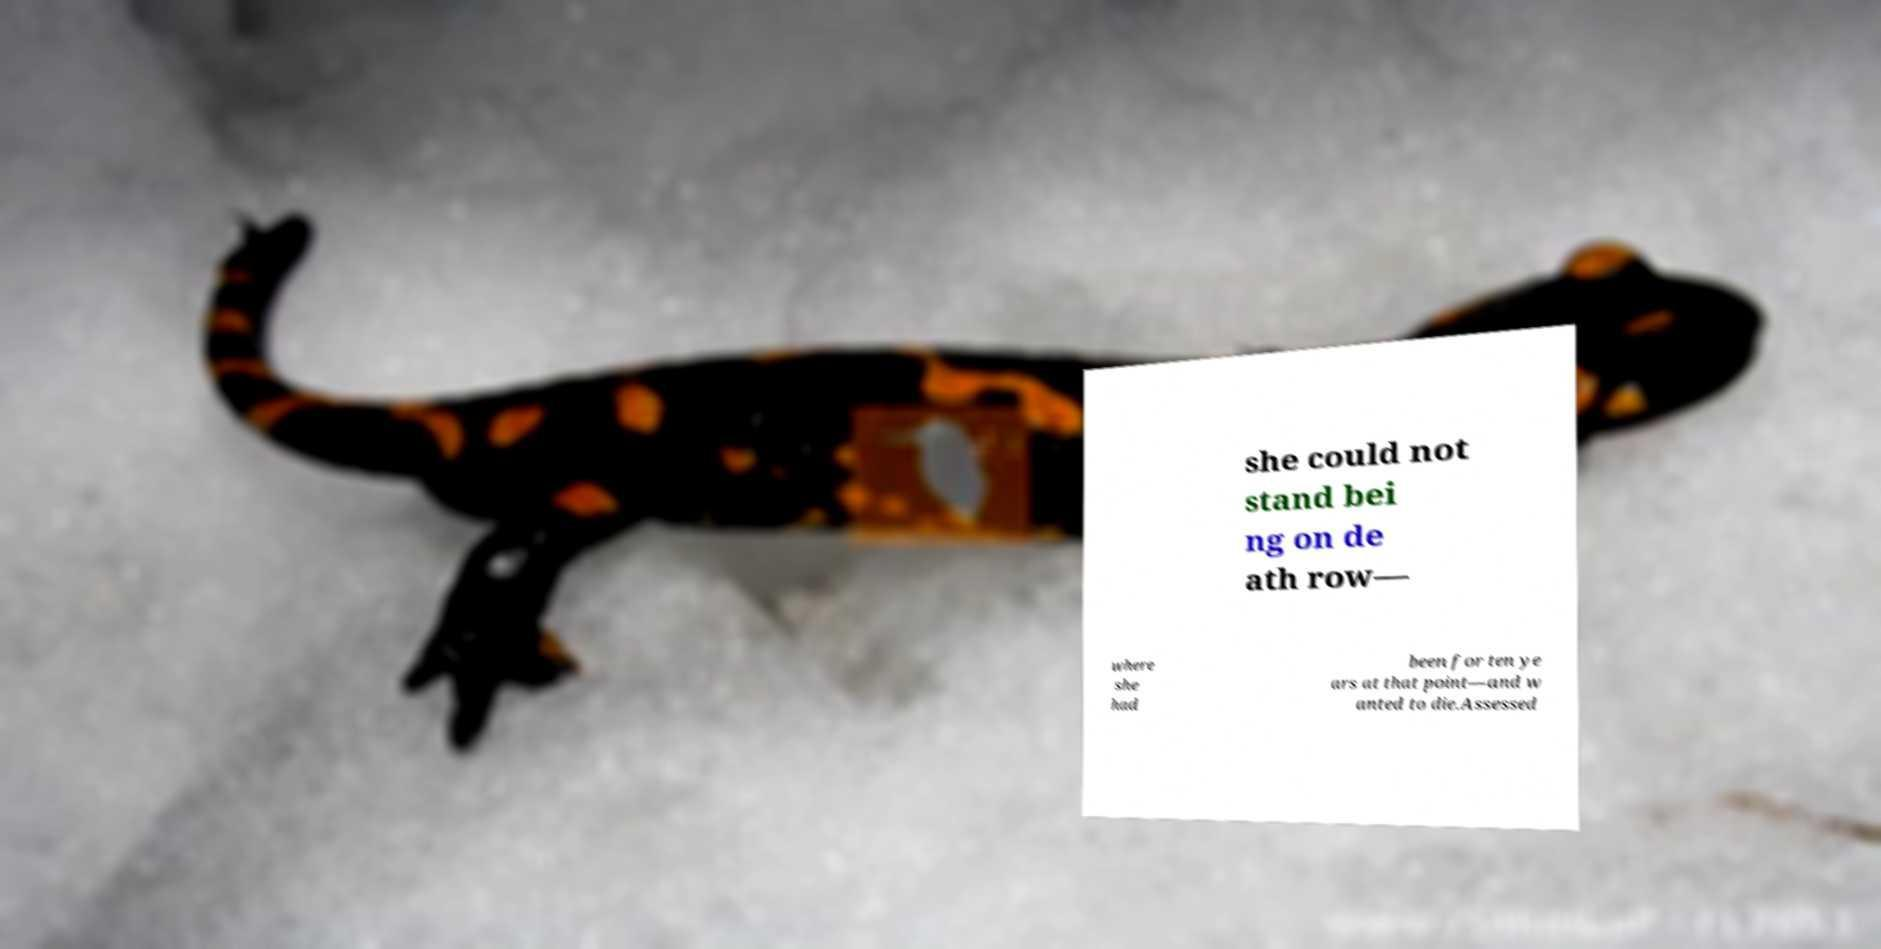Please identify and transcribe the text found in this image. she could not stand bei ng on de ath row— where she had been for ten ye ars at that point—and w anted to die.Assessed 